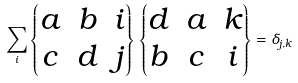Convert formula to latex. <formula><loc_0><loc_0><loc_500><loc_500>\sum _ { i } \begin{Bmatrix} a & b & i \\ c & d & j \end{Bmatrix} \, \begin{Bmatrix} d & a & k \\ b & c & i \end{Bmatrix} = \delta _ { j , k }</formula> 